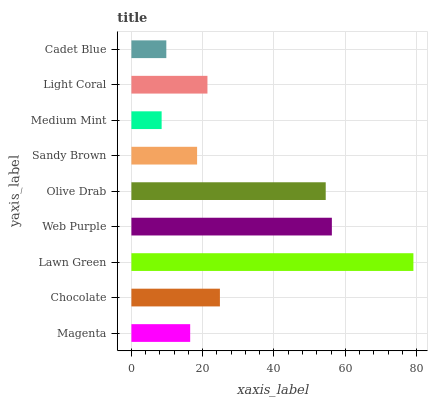Is Medium Mint the minimum?
Answer yes or no. Yes. Is Lawn Green the maximum?
Answer yes or no. Yes. Is Chocolate the minimum?
Answer yes or no. No. Is Chocolate the maximum?
Answer yes or no. No. Is Chocolate greater than Magenta?
Answer yes or no. Yes. Is Magenta less than Chocolate?
Answer yes or no. Yes. Is Magenta greater than Chocolate?
Answer yes or no. No. Is Chocolate less than Magenta?
Answer yes or no. No. Is Light Coral the high median?
Answer yes or no. Yes. Is Light Coral the low median?
Answer yes or no. Yes. Is Medium Mint the high median?
Answer yes or no. No. Is Sandy Brown the low median?
Answer yes or no. No. 